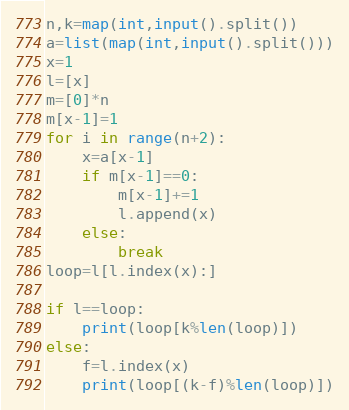Convert code to text. <code><loc_0><loc_0><loc_500><loc_500><_Python_>n,k=map(int,input().split())
a=list(map(int,input().split()))
x=1
l=[x]
m=[0]*n
m[x-1]=1
for i in range(n+2):
    x=a[x-1]
    if m[x-1]==0:
        m[x-1]+=1
        l.append(x)
    else:
        break
loop=l[l.index(x):]

if l==loop:
    print(loop[k%len(loop)])
else:
    f=l.index(x)
    print(loop[(k-f)%len(loop)])
</code> 